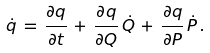Convert formula to latex. <formula><loc_0><loc_0><loc_500><loc_500>\dot { q } \, = \, \frac { \partial q } { \partial t } \, + \, \frac { \partial q } { \partial Q } \, \dot { Q } \, + \, \frac { \partial q } { \partial P } \, \dot { P } \, .</formula> 